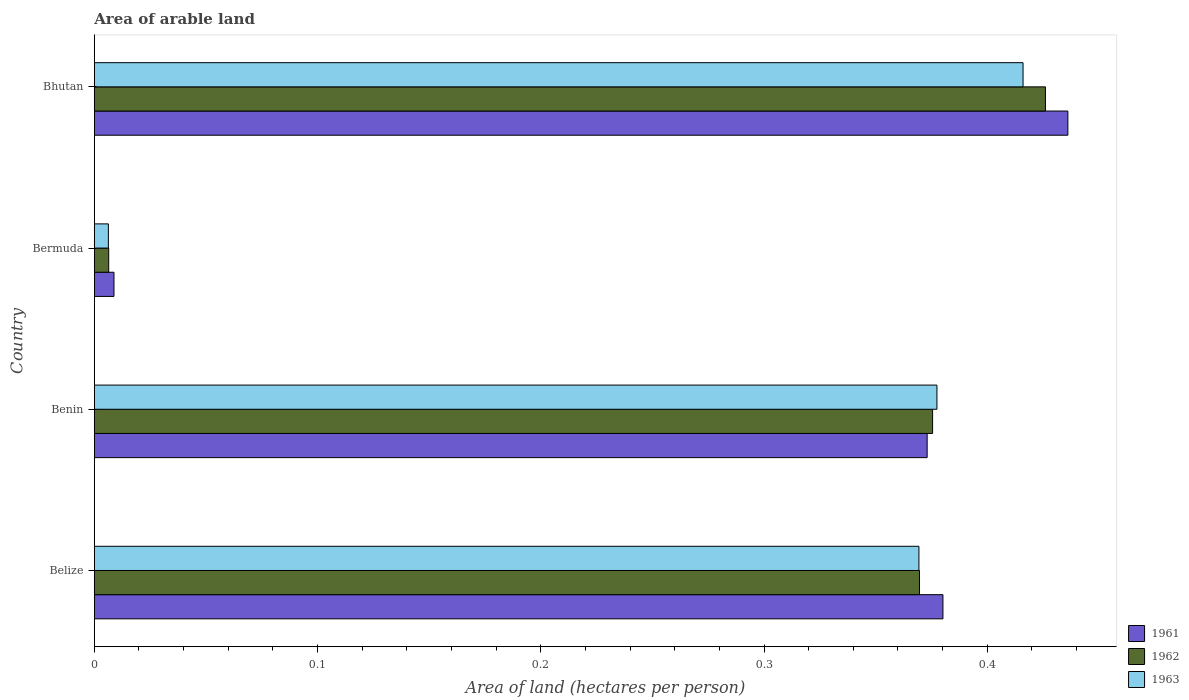How many groups of bars are there?
Offer a very short reply. 4. What is the label of the 3rd group of bars from the top?
Offer a terse response. Benin. In how many cases, is the number of bars for a given country not equal to the number of legend labels?
Provide a succinct answer. 0. What is the total arable land in 1961 in Bhutan?
Keep it short and to the point. 0.44. Across all countries, what is the maximum total arable land in 1963?
Provide a short and direct response. 0.42. Across all countries, what is the minimum total arable land in 1961?
Give a very brief answer. 0.01. In which country was the total arable land in 1962 maximum?
Your response must be concise. Bhutan. In which country was the total arable land in 1962 minimum?
Keep it short and to the point. Bermuda. What is the total total arable land in 1962 in the graph?
Provide a succinct answer. 1.18. What is the difference between the total arable land in 1963 in Belize and that in Bermuda?
Provide a short and direct response. 0.36. What is the difference between the total arable land in 1961 in Bhutan and the total arable land in 1962 in Belize?
Provide a short and direct response. 0.07. What is the average total arable land in 1962 per country?
Give a very brief answer. 0.29. What is the difference between the total arable land in 1962 and total arable land in 1963 in Belize?
Your answer should be compact. 0. In how many countries, is the total arable land in 1962 greater than 0.26 hectares per person?
Make the answer very short. 3. What is the ratio of the total arable land in 1962 in Belize to that in Benin?
Provide a short and direct response. 0.98. What is the difference between the highest and the second highest total arable land in 1962?
Offer a very short reply. 0.05. What is the difference between the highest and the lowest total arable land in 1963?
Give a very brief answer. 0.41. What does the 2nd bar from the top in Benin represents?
Keep it short and to the point. 1962. How many bars are there?
Offer a very short reply. 12. How many countries are there in the graph?
Keep it short and to the point. 4. What is the difference between two consecutive major ticks on the X-axis?
Your answer should be compact. 0.1. What is the title of the graph?
Keep it short and to the point. Area of arable land. What is the label or title of the X-axis?
Your response must be concise. Area of land (hectares per person). What is the label or title of the Y-axis?
Provide a short and direct response. Country. What is the Area of land (hectares per person) in 1961 in Belize?
Provide a short and direct response. 0.38. What is the Area of land (hectares per person) in 1962 in Belize?
Offer a very short reply. 0.37. What is the Area of land (hectares per person) in 1963 in Belize?
Keep it short and to the point. 0.37. What is the Area of land (hectares per person) of 1961 in Benin?
Your answer should be very brief. 0.37. What is the Area of land (hectares per person) in 1962 in Benin?
Your response must be concise. 0.38. What is the Area of land (hectares per person) of 1963 in Benin?
Your answer should be very brief. 0.38. What is the Area of land (hectares per person) of 1961 in Bermuda?
Your response must be concise. 0.01. What is the Area of land (hectares per person) in 1962 in Bermuda?
Your answer should be compact. 0.01. What is the Area of land (hectares per person) of 1963 in Bermuda?
Offer a terse response. 0.01. What is the Area of land (hectares per person) in 1961 in Bhutan?
Give a very brief answer. 0.44. What is the Area of land (hectares per person) of 1962 in Bhutan?
Provide a succinct answer. 0.43. What is the Area of land (hectares per person) of 1963 in Bhutan?
Provide a short and direct response. 0.42. Across all countries, what is the maximum Area of land (hectares per person) of 1961?
Offer a very short reply. 0.44. Across all countries, what is the maximum Area of land (hectares per person) of 1962?
Give a very brief answer. 0.43. Across all countries, what is the maximum Area of land (hectares per person) in 1963?
Your answer should be very brief. 0.42. Across all countries, what is the minimum Area of land (hectares per person) of 1961?
Offer a very short reply. 0.01. Across all countries, what is the minimum Area of land (hectares per person) of 1962?
Offer a very short reply. 0.01. Across all countries, what is the minimum Area of land (hectares per person) of 1963?
Your answer should be compact. 0.01. What is the total Area of land (hectares per person) in 1961 in the graph?
Offer a terse response. 1.2. What is the total Area of land (hectares per person) in 1962 in the graph?
Your answer should be compact. 1.18. What is the total Area of land (hectares per person) of 1963 in the graph?
Provide a succinct answer. 1.17. What is the difference between the Area of land (hectares per person) of 1961 in Belize and that in Benin?
Provide a succinct answer. 0.01. What is the difference between the Area of land (hectares per person) in 1962 in Belize and that in Benin?
Your response must be concise. -0.01. What is the difference between the Area of land (hectares per person) in 1963 in Belize and that in Benin?
Provide a succinct answer. -0.01. What is the difference between the Area of land (hectares per person) of 1961 in Belize and that in Bermuda?
Provide a succinct answer. 0.37. What is the difference between the Area of land (hectares per person) of 1962 in Belize and that in Bermuda?
Offer a terse response. 0.36. What is the difference between the Area of land (hectares per person) in 1963 in Belize and that in Bermuda?
Keep it short and to the point. 0.36. What is the difference between the Area of land (hectares per person) in 1961 in Belize and that in Bhutan?
Offer a terse response. -0.06. What is the difference between the Area of land (hectares per person) in 1962 in Belize and that in Bhutan?
Provide a short and direct response. -0.06. What is the difference between the Area of land (hectares per person) in 1963 in Belize and that in Bhutan?
Ensure brevity in your answer.  -0.05. What is the difference between the Area of land (hectares per person) in 1961 in Benin and that in Bermuda?
Ensure brevity in your answer.  0.36. What is the difference between the Area of land (hectares per person) in 1962 in Benin and that in Bermuda?
Your answer should be very brief. 0.37. What is the difference between the Area of land (hectares per person) in 1963 in Benin and that in Bermuda?
Your answer should be compact. 0.37. What is the difference between the Area of land (hectares per person) of 1961 in Benin and that in Bhutan?
Your answer should be very brief. -0.06. What is the difference between the Area of land (hectares per person) in 1962 in Benin and that in Bhutan?
Make the answer very short. -0.05. What is the difference between the Area of land (hectares per person) of 1963 in Benin and that in Bhutan?
Make the answer very short. -0.04. What is the difference between the Area of land (hectares per person) of 1961 in Bermuda and that in Bhutan?
Your answer should be very brief. -0.43. What is the difference between the Area of land (hectares per person) of 1962 in Bermuda and that in Bhutan?
Your answer should be very brief. -0.42. What is the difference between the Area of land (hectares per person) in 1963 in Bermuda and that in Bhutan?
Provide a short and direct response. -0.41. What is the difference between the Area of land (hectares per person) of 1961 in Belize and the Area of land (hectares per person) of 1962 in Benin?
Give a very brief answer. 0. What is the difference between the Area of land (hectares per person) in 1961 in Belize and the Area of land (hectares per person) in 1963 in Benin?
Keep it short and to the point. 0. What is the difference between the Area of land (hectares per person) of 1962 in Belize and the Area of land (hectares per person) of 1963 in Benin?
Your response must be concise. -0.01. What is the difference between the Area of land (hectares per person) of 1961 in Belize and the Area of land (hectares per person) of 1962 in Bermuda?
Offer a terse response. 0.37. What is the difference between the Area of land (hectares per person) of 1961 in Belize and the Area of land (hectares per person) of 1963 in Bermuda?
Offer a very short reply. 0.37. What is the difference between the Area of land (hectares per person) in 1962 in Belize and the Area of land (hectares per person) in 1963 in Bermuda?
Ensure brevity in your answer.  0.36. What is the difference between the Area of land (hectares per person) in 1961 in Belize and the Area of land (hectares per person) in 1962 in Bhutan?
Offer a terse response. -0.05. What is the difference between the Area of land (hectares per person) of 1961 in Belize and the Area of land (hectares per person) of 1963 in Bhutan?
Ensure brevity in your answer.  -0.04. What is the difference between the Area of land (hectares per person) of 1962 in Belize and the Area of land (hectares per person) of 1963 in Bhutan?
Keep it short and to the point. -0.05. What is the difference between the Area of land (hectares per person) in 1961 in Benin and the Area of land (hectares per person) in 1962 in Bermuda?
Your answer should be very brief. 0.37. What is the difference between the Area of land (hectares per person) in 1961 in Benin and the Area of land (hectares per person) in 1963 in Bermuda?
Your answer should be compact. 0.37. What is the difference between the Area of land (hectares per person) of 1962 in Benin and the Area of land (hectares per person) of 1963 in Bermuda?
Keep it short and to the point. 0.37. What is the difference between the Area of land (hectares per person) of 1961 in Benin and the Area of land (hectares per person) of 1962 in Bhutan?
Provide a succinct answer. -0.05. What is the difference between the Area of land (hectares per person) in 1961 in Benin and the Area of land (hectares per person) in 1963 in Bhutan?
Make the answer very short. -0.04. What is the difference between the Area of land (hectares per person) in 1962 in Benin and the Area of land (hectares per person) in 1963 in Bhutan?
Offer a terse response. -0.04. What is the difference between the Area of land (hectares per person) of 1961 in Bermuda and the Area of land (hectares per person) of 1962 in Bhutan?
Your answer should be compact. -0.42. What is the difference between the Area of land (hectares per person) of 1961 in Bermuda and the Area of land (hectares per person) of 1963 in Bhutan?
Your answer should be very brief. -0.41. What is the difference between the Area of land (hectares per person) of 1962 in Bermuda and the Area of land (hectares per person) of 1963 in Bhutan?
Your response must be concise. -0.41. What is the average Area of land (hectares per person) in 1961 per country?
Keep it short and to the point. 0.3. What is the average Area of land (hectares per person) in 1962 per country?
Make the answer very short. 0.29. What is the average Area of land (hectares per person) in 1963 per country?
Provide a succinct answer. 0.29. What is the difference between the Area of land (hectares per person) of 1961 and Area of land (hectares per person) of 1962 in Belize?
Ensure brevity in your answer.  0.01. What is the difference between the Area of land (hectares per person) of 1961 and Area of land (hectares per person) of 1963 in Belize?
Your answer should be very brief. 0.01. What is the difference between the Area of land (hectares per person) of 1962 and Area of land (hectares per person) of 1963 in Belize?
Your answer should be very brief. 0. What is the difference between the Area of land (hectares per person) of 1961 and Area of land (hectares per person) of 1962 in Benin?
Your answer should be very brief. -0. What is the difference between the Area of land (hectares per person) of 1961 and Area of land (hectares per person) of 1963 in Benin?
Give a very brief answer. -0. What is the difference between the Area of land (hectares per person) in 1962 and Area of land (hectares per person) in 1963 in Benin?
Your answer should be very brief. -0. What is the difference between the Area of land (hectares per person) in 1961 and Area of land (hectares per person) in 1962 in Bermuda?
Make the answer very short. 0. What is the difference between the Area of land (hectares per person) of 1961 and Area of land (hectares per person) of 1963 in Bermuda?
Keep it short and to the point. 0. What is the difference between the Area of land (hectares per person) in 1962 and Area of land (hectares per person) in 1963 in Bermuda?
Your answer should be compact. 0. What is the difference between the Area of land (hectares per person) in 1961 and Area of land (hectares per person) in 1963 in Bhutan?
Ensure brevity in your answer.  0.02. What is the difference between the Area of land (hectares per person) of 1962 and Area of land (hectares per person) of 1963 in Bhutan?
Offer a very short reply. 0.01. What is the ratio of the Area of land (hectares per person) of 1962 in Belize to that in Benin?
Your answer should be very brief. 0.98. What is the ratio of the Area of land (hectares per person) of 1963 in Belize to that in Benin?
Provide a succinct answer. 0.98. What is the ratio of the Area of land (hectares per person) in 1961 in Belize to that in Bermuda?
Offer a terse response. 43.24. What is the ratio of the Area of land (hectares per person) in 1962 in Belize to that in Bermuda?
Offer a very short reply. 57.42. What is the ratio of the Area of land (hectares per person) in 1963 in Belize to that in Bermuda?
Offer a terse response. 58.73. What is the ratio of the Area of land (hectares per person) in 1961 in Belize to that in Bhutan?
Keep it short and to the point. 0.87. What is the ratio of the Area of land (hectares per person) of 1962 in Belize to that in Bhutan?
Give a very brief answer. 0.87. What is the ratio of the Area of land (hectares per person) in 1963 in Belize to that in Bhutan?
Provide a succinct answer. 0.89. What is the ratio of the Area of land (hectares per person) in 1961 in Benin to that in Bermuda?
Your answer should be compact. 42.44. What is the ratio of the Area of land (hectares per person) of 1962 in Benin to that in Bermuda?
Offer a very short reply. 58.33. What is the ratio of the Area of land (hectares per person) of 1963 in Benin to that in Bermuda?
Your answer should be very brief. 60.02. What is the ratio of the Area of land (hectares per person) of 1961 in Benin to that in Bhutan?
Your answer should be compact. 0.86. What is the ratio of the Area of land (hectares per person) of 1962 in Benin to that in Bhutan?
Your answer should be very brief. 0.88. What is the ratio of the Area of land (hectares per person) of 1963 in Benin to that in Bhutan?
Keep it short and to the point. 0.91. What is the ratio of the Area of land (hectares per person) of 1961 in Bermuda to that in Bhutan?
Give a very brief answer. 0.02. What is the ratio of the Area of land (hectares per person) of 1962 in Bermuda to that in Bhutan?
Your response must be concise. 0.02. What is the ratio of the Area of land (hectares per person) of 1963 in Bermuda to that in Bhutan?
Provide a short and direct response. 0.02. What is the difference between the highest and the second highest Area of land (hectares per person) in 1961?
Keep it short and to the point. 0.06. What is the difference between the highest and the second highest Area of land (hectares per person) in 1962?
Offer a very short reply. 0.05. What is the difference between the highest and the second highest Area of land (hectares per person) in 1963?
Make the answer very short. 0.04. What is the difference between the highest and the lowest Area of land (hectares per person) in 1961?
Your answer should be compact. 0.43. What is the difference between the highest and the lowest Area of land (hectares per person) of 1962?
Your answer should be compact. 0.42. What is the difference between the highest and the lowest Area of land (hectares per person) in 1963?
Give a very brief answer. 0.41. 